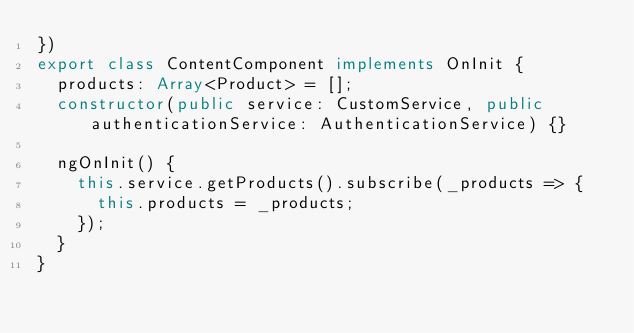<code> <loc_0><loc_0><loc_500><loc_500><_TypeScript_>})
export class ContentComponent implements OnInit {
  products: Array<Product> = [];
  constructor(public service: CustomService, public authenticationService: AuthenticationService) {}

  ngOnInit() {
    this.service.getProducts().subscribe(_products => {
      this.products = _products;
    });
  }
}
</code> 